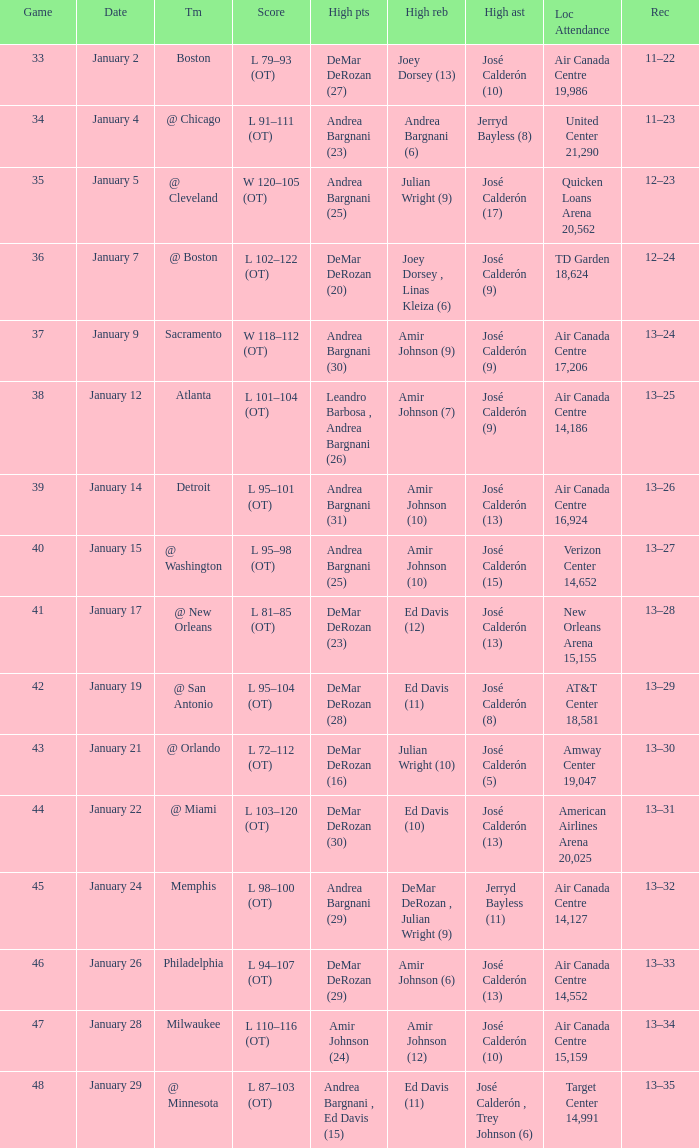Name the team for score l 102–122 (ot) @ Boston. 